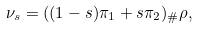<formula> <loc_0><loc_0><loc_500><loc_500>\nu _ { s } = ( ( 1 - s ) \pi _ { 1 } + s \pi _ { 2 } ) _ { \# } \rho ,</formula> 